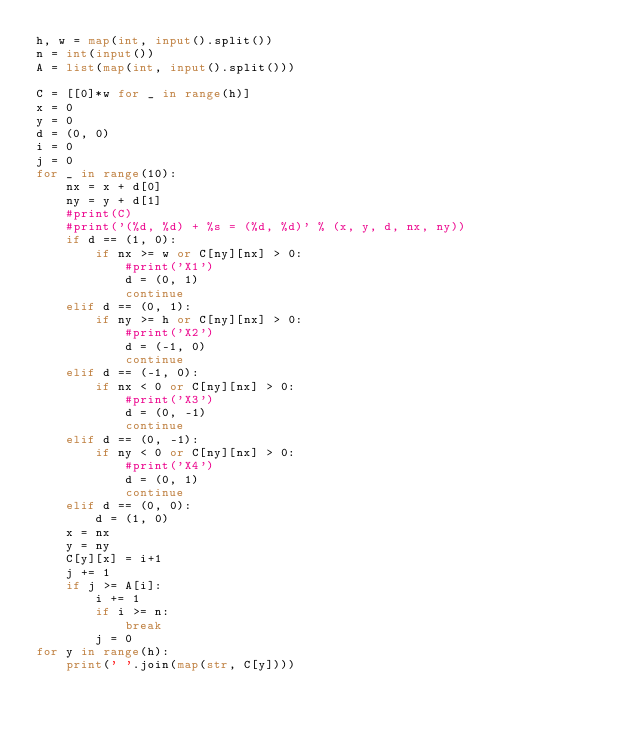Convert code to text. <code><loc_0><loc_0><loc_500><loc_500><_Python_>h, w = map(int, input().split())
n = int(input())
A = list(map(int, input().split()))

C = [[0]*w for _ in range(h)]
x = 0
y = 0
d = (0, 0)
i = 0
j = 0
for _ in range(10):
    nx = x + d[0]
    ny = y + d[1]
    #print(C)
    #print('(%d, %d) + %s = (%d, %d)' % (x, y, d, nx, ny))
    if d == (1, 0):
        if nx >= w or C[ny][nx] > 0:
            #print('X1')
            d = (0, 1)
            continue
    elif d == (0, 1):
        if ny >= h or C[ny][nx] > 0:
            #print('X2')
            d = (-1, 0)
            continue
    elif d == (-1, 0):
        if nx < 0 or C[ny][nx] > 0:
            #print('X3')
            d = (0, -1)
            continue
    elif d == (0, -1):
        if ny < 0 or C[ny][nx] > 0:
            #print('X4')
            d = (0, 1)
            continue
    elif d == (0, 0):
        d = (1, 0)
    x = nx
    y = ny
    C[y][x] = i+1
    j += 1
    if j >= A[i]:
        i += 1
        if i >= n:
            break
        j = 0
for y in range(h):
    print(' '.join(map(str, C[y])))
</code> 